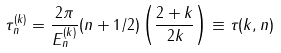Convert formula to latex. <formula><loc_0><loc_0><loc_500><loc_500>\tau _ { n } ^ { ( k ) } = \frac { 2 \pi } { E _ { n } ^ { ( k ) } } ( n + 1 / 2 ) \left ( \frac { 2 + k } { 2 k } \right ) \equiv \tau ( k , n )</formula> 